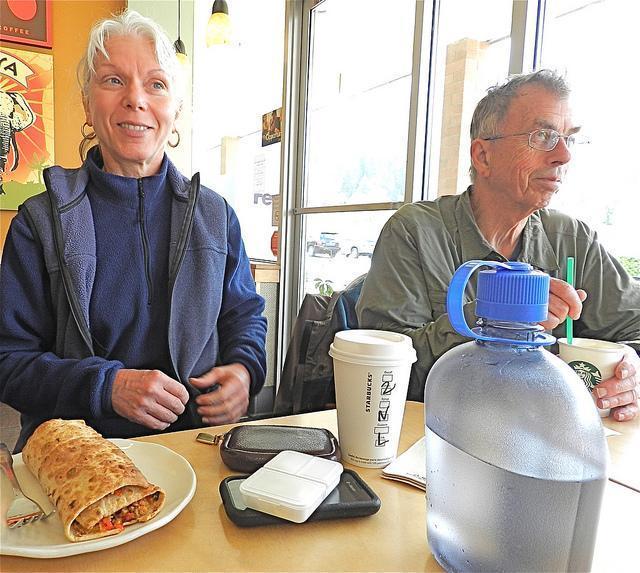How many people are there?
Give a very brief answer. 2. How many dining tables are visible?
Give a very brief answer. 2. How many cups are there?
Give a very brief answer. 2. 